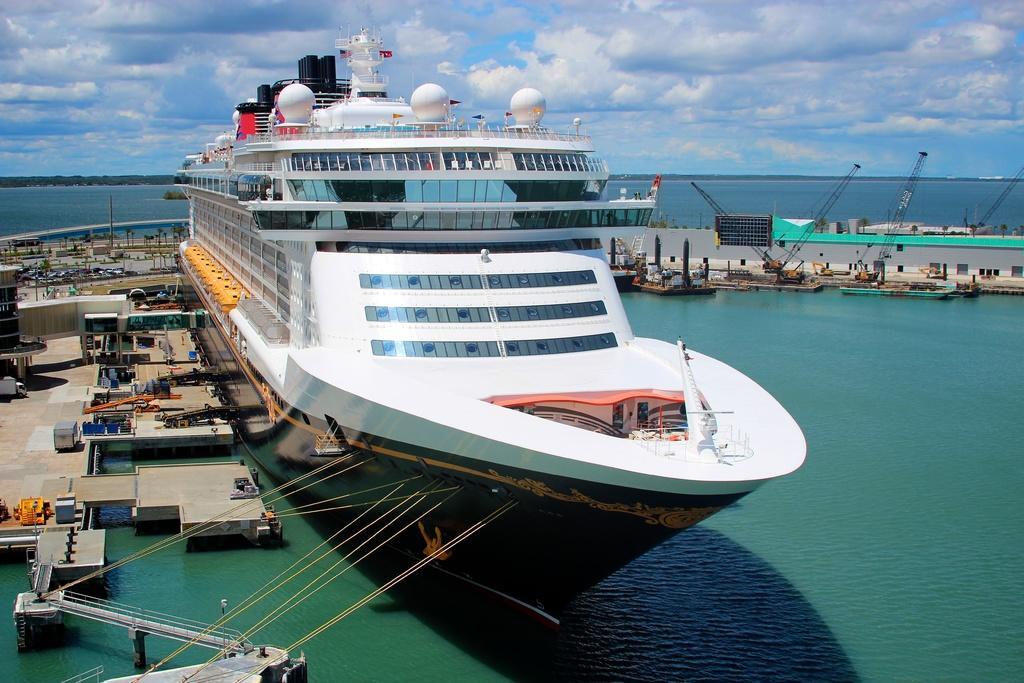Please provide a concise description of this image. At the bottom of the image I can see the water. It is looking like an ocean. In the middle of the image there is a ship on the water. On the left side, I can see the platform on the water which is made up of wood. On this I can see many metal objects are placed. On the right side there are some boats. At the top I can see the sky and clouds. 